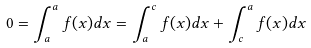<formula> <loc_0><loc_0><loc_500><loc_500>0 = \int _ { a } ^ { a } f ( x ) d x = \int _ { a } ^ { c } f ( x ) d x + \int _ { c } ^ { a } f ( x ) d x</formula> 